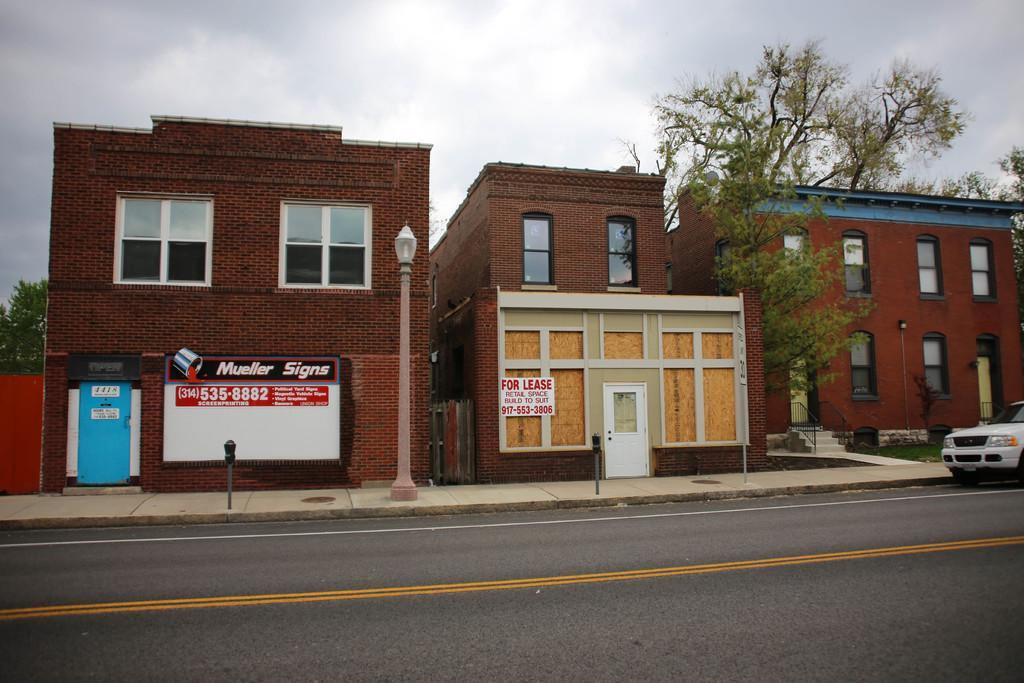Can you describe this image briefly? In this picture there are buildings in the center of the image and there are windows on the buildings and there are trees on the right and left side of the image, there is a car on the right side of the image, there is a lamp pole in the center of the image. 